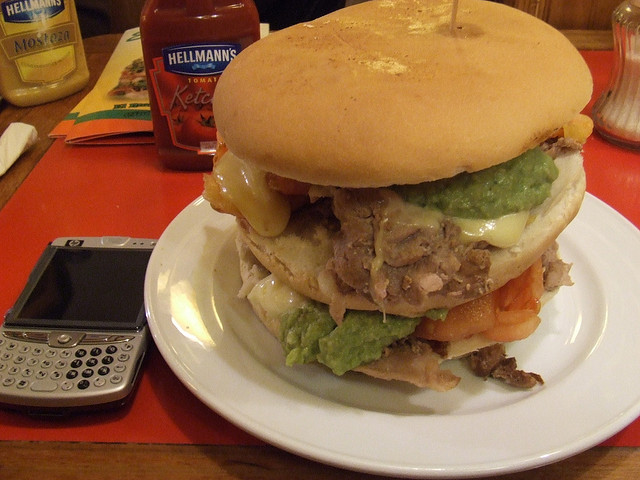Identify the text contained in this image. HELLMANN'S Ketc M0STOZA 